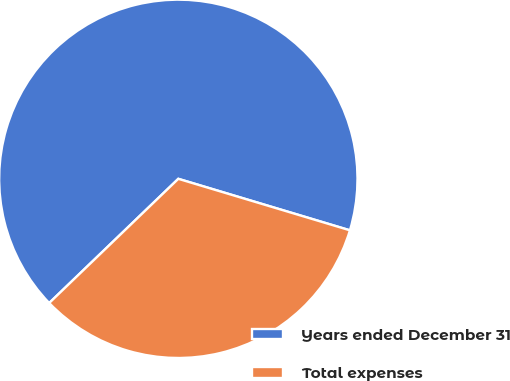Convert chart to OTSL. <chart><loc_0><loc_0><loc_500><loc_500><pie_chart><fcel>Years ended December 31<fcel>Total expenses<nl><fcel>66.83%<fcel>33.17%<nl></chart> 